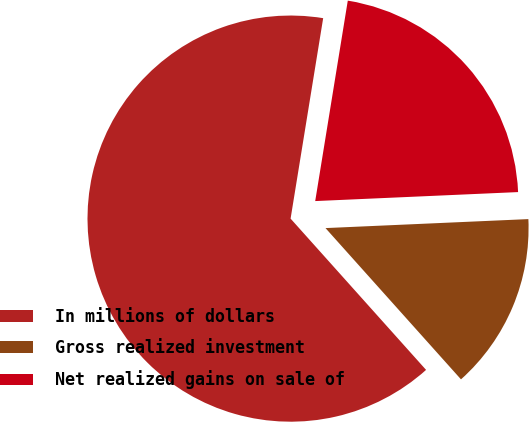<chart> <loc_0><loc_0><loc_500><loc_500><pie_chart><fcel>In millions of dollars<fcel>Gross realized investment<fcel>Net realized gains on sale of<nl><fcel>64.19%<fcel>14.08%<fcel>21.73%<nl></chart> 